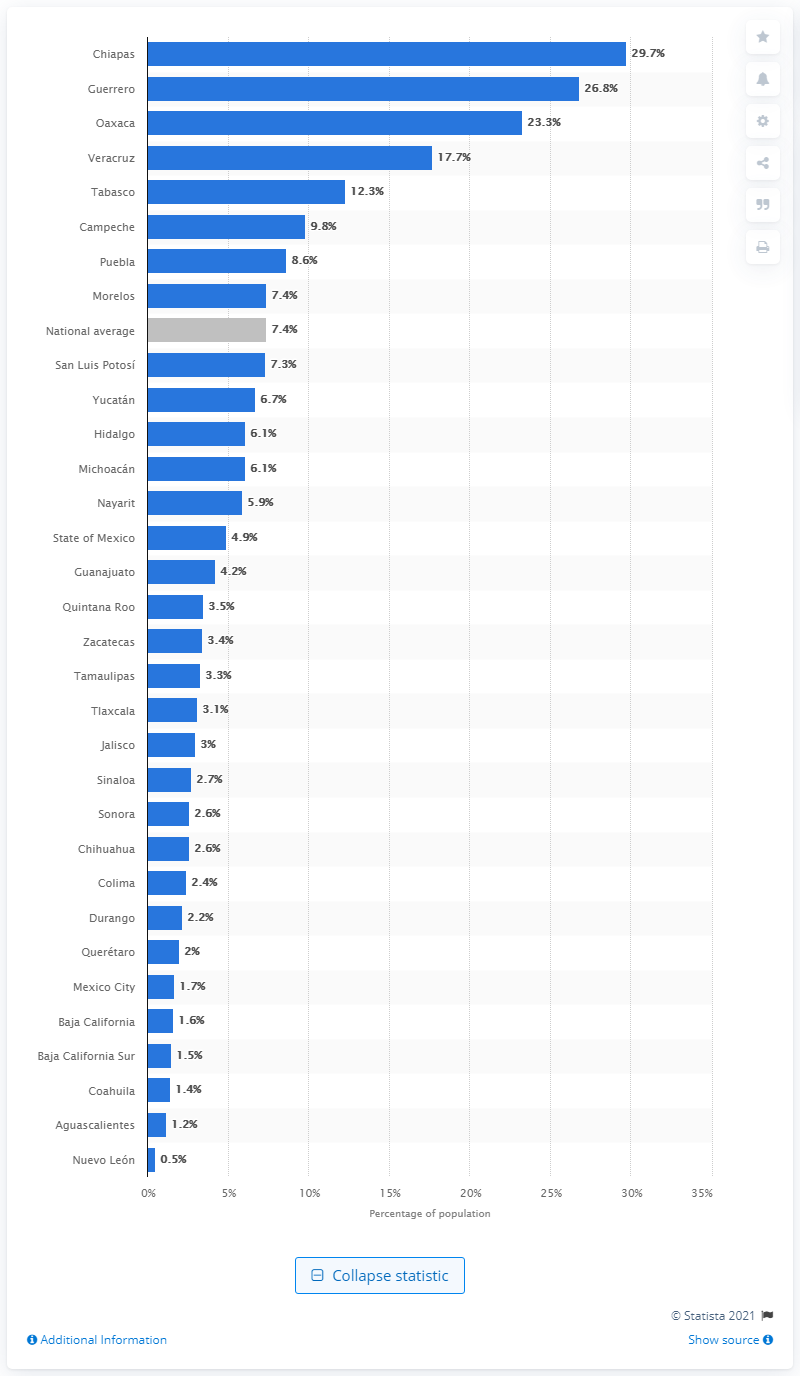Point out several critical features in this image. In 2018, Chiapas had the highest extreme poverty rate among all states in Mexico. 